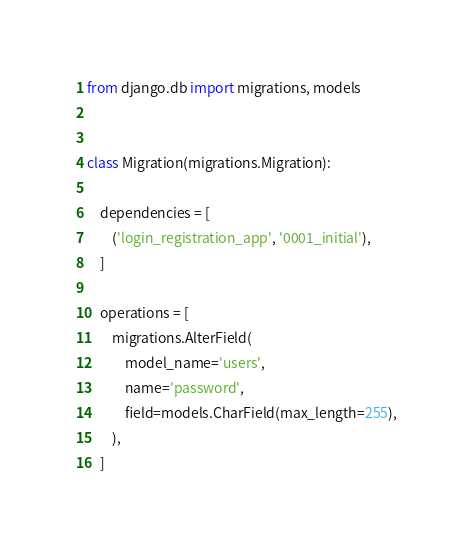<code> <loc_0><loc_0><loc_500><loc_500><_Python_>
from django.db import migrations, models


class Migration(migrations.Migration):

    dependencies = [
        ('login_registration_app', '0001_initial'),
    ]

    operations = [
        migrations.AlterField(
            model_name='users',
            name='password',
            field=models.CharField(max_length=255),
        ),
    ]
</code> 